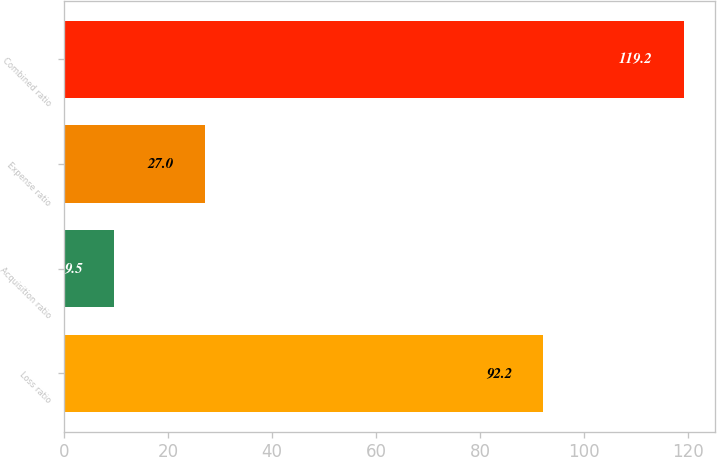<chart> <loc_0><loc_0><loc_500><loc_500><bar_chart><fcel>Loss ratio<fcel>Acquisition ratio<fcel>Expense ratio<fcel>Combined ratio<nl><fcel>92.2<fcel>9.5<fcel>27<fcel>119.2<nl></chart> 